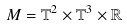<formula> <loc_0><loc_0><loc_500><loc_500>M = \mathbb { T } ^ { 2 } \times \mathbb { T } ^ { 3 } \times \mathbb { R }</formula> 